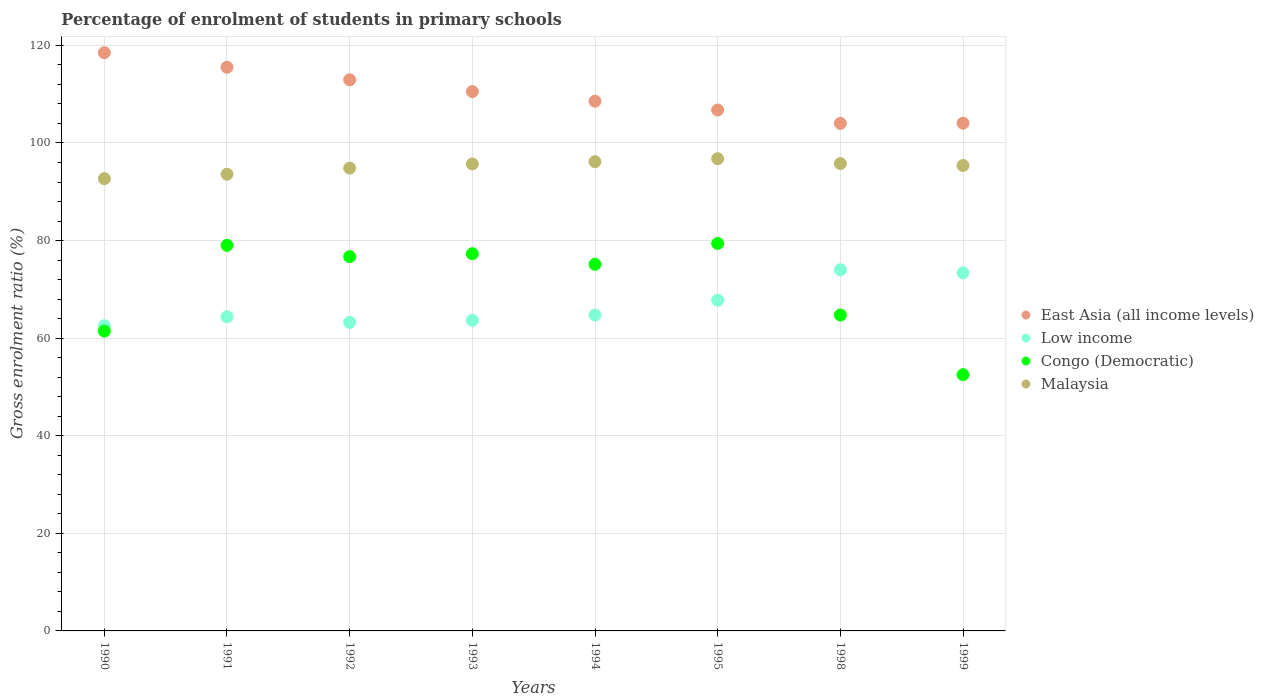Is the number of dotlines equal to the number of legend labels?
Make the answer very short. Yes. What is the percentage of students enrolled in primary schools in East Asia (all income levels) in 1993?
Give a very brief answer. 110.53. Across all years, what is the maximum percentage of students enrolled in primary schools in Low income?
Your response must be concise. 74.02. Across all years, what is the minimum percentage of students enrolled in primary schools in East Asia (all income levels)?
Ensure brevity in your answer.  104.02. In which year was the percentage of students enrolled in primary schools in Low income minimum?
Offer a terse response. 1990. What is the total percentage of students enrolled in primary schools in Low income in the graph?
Your answer should be compact. 533.71. What is the difference between the percentage of students enrolled in primary schools in Low income in 1998 and that in 1999?
Keep it short and to the point. 0.63. What is the difference between the percentage of students enrolled in primary schools in East Asia (all income levels) in 1991 and the percentage of students enrolled in primary schools in Malaysia in 1995?
Offer a very short reply. 18.74. What is the average percentage of students enrolled in primary schools in East Asia (all income levels) per year?
Keep it short and to the point. 110.11. In the year 1992, what is the difference between the percentage of students enrolled in primary schools in Congo (Democratic) and percentage of students enrolled in primary schools in Malaysia?
Ensure brevity in your answer.  -18.15. In how many years, is the percentage of students enrolled in primary schools in Malaysia greater than 44 %?
Keep it short and to the point. 8. What is the ratio of the percentage of students enrolled in primary schools in Congo (Democratic) in 1992 to that in 1998?
Your answer should be compact. 1.18. What is the difference between the highest and the second highest percentage of students enrolled in primary schools in Malaysia?
Your answer should be very brief. 0.61. What is the difference between the highest and the lowest percentage of students enrolled in primary schools in Congo (Democratic)?
Your answer should be very brief. 26.9. Is it the case that in every year, the sum of the percentage of students enrolled in primary schools in Congo (Democratic) and percentage of students enrolled in primary schools in Low income  is greater than the percentage of students enrolled in primary schools in Malaysia?
Your answer should be very brief. Yes. Does the percentage of students enrolled in primary schools in Congo (Democratic) monotonically increase over the years?
Keep it short and to the point. No. Is the percentage of students enrolled in primary schools in East Asia (all income levels) strictly less than the percentage of students enrolled in primary schools in Congo (Democratic) over the years?
Provide a short and direct response. No. What is the difference between two consecutive major ticks on the Y-axis?
Your response must be concise. 20. Are the values on the major ticks of Y-axis written in scientific E-notation?
Your response must be concise. No. Does the graph contain any zero values?
Offer a very short reply. No. Does the graph contain grids?
Your response must be concise. Yes. Where does the legend appear in the graph?
Make the answer very short. Center right. How are the legend labels stacked?
Provide a succinct answer. Vertical. What is the title of the graph?
Make the answer very short. Percentage of enrolment of students in primary schools. What is the Gross enrolment ratio (%) of East Asia (all income levels) in 1990?
Give a very brief answer. 118.51. What is the Gross enrolment ratio (%) of Low income in 1990?
Provide a succinct answer. 62.54. What is the Gross enrolment ratio (%) of Congo (Democratic) in 1990?
Offer a terse response. 61.45. What is the Gross enrolment ratio (%) of Malaysia in 1990?
Your answer should be very brief. 92.69. What is the Gross enrolment ratio (%) of East Asia (all income levels) in 1991?
Your answer should be compact. 115.52. What is the Gross enrolment ratio (%) of Low income in 1991?
Your answer should be very brief. 64.38. What is the Gross enrolment ratio (%) in Congo (Democratic) in 1991?
Offer a terse response. 79.03. What is the Gross enrolment ratio (%) of Malaysia in 1991?
Provide a short and direct response. 93.6. What is the Gross enrolment ratio (%) of East Asia (all income levels) in 1992?
Offer a very short reply. 112.94. What is the Gross enrolment ratio (%) of Low income in 1992?
Make the answer very short. 63.23. What is the Gross enrolment ratio (%) of Congo (Democratic) in 1992?
Your answer should be compact. 76.7. What is the Gross enrolment ratio (%) in Malaysia in 1992?
Keep it short and to the point. 94.85. What is the Gross enrolment ratio (%) of East Asia (all income levels) in 1993?
Your answer should be very brief. 110.53. What is the Gross enrolment ratio (%) in Low income in 1993?
Make the answer very short. 63.64. What is the Gross enrolment ratio (%) of Congo (Democratic) in 1993?
Your answer should be compact. 77.31. What is the Gross enrolment ratio (%) of Malaysia in 1993?
Your answer should be compact. 95.7. What is the Gross enrolment ratio (%) in East Asia (all income levels) in 1994?
Provide a succinct answer. 108.56. What is the Gross enrolment ratio (%) of Low income in 1994?
Offer a very short reply. 64.74. What is the Gross enrolment ratio (%) of Congo (Democratic) in 1994?
Ensure brevity in your answer.  75.14. What is the Gross enrolment ratio (%) of Malaysia in 1994?
Give a very brief answer. 96.17. What is the Gross enrolment ratio (%) of East Asia (all income levels) in 1995?
Your response must be concise. 106.77. What is the Gross enrolment ratio (%) of Low income in 1995?
Make the answer very short. 67.78. What is the Gross enrolment ratio (%) in Congo (Democratic) in 1995?
Keep it short and to the point. 79.41. What is the Gross enrolment ratio (%) of Malaysia in 1995?
Give a very brief answer. 96.78. What is the Gross enrolment ratio (%) in East Asia (all income levels) in 1998?
Keep it short and to the point. 104.02. What is the Gross enrolment ratio (%) in Low income in 1998?
Your response must be concise. 74.02. What is the Gross enrolment ratio (%) of Congo (Democratic) in 1998?
Provide a succinct answer. 64.74. What is the Gross enrolment ratio (%) in Malaysia in 1998?
Provide a short and direct response. 95.79. What is the Gross enrolment ratio (%) of East Asia (all income levels) in 1999?
Give a very brief answer. 104.06. What is the Gross enrolment ratio (%) in Low income in 1999?
Offer a very short reply. 73.39. What is the Gross enrolment ratio (%) in Congo (Democratic) in 1999?
Offer a terse response. 52.51. What is the Gross enrolment ratio (%) of Malaysia in 1999?
Make the answer very short. 95.39. Across all years, what is the maximum Gross enrolment ratio (%) in East Asia (all income levels)?
Your answer should be very brief. 118.51. Across all years, what is the maximum Gross enrolment ratio (%) in Low income?
Provide a short and direct response. 74.02. Across all years, what is the maximum Gross enrolment ratio (%) of Congo (Democratic)?
Offer a terse response. 79.41. Across all years, what is the maximum Gross enrolment ratio (%) of Malaysia?
Offer a very short reply. 96.78. Across all years, what is the minimum Gross enrolment ratio (%) of East Asia (all income levels)?
Keep it short and to the point. 104.02. Across all years, what is the minimum Gross enrolment ratio (%) of Low income?
Your response must be concise. 62.54. Across all years, what is the minimum Gross enrolment ratio (%) in Congo (Democratic)?
Provide a short and direct response. 52.51. Across all years, what is the minimum Gross enrolment ratio (%) in Malaysia?
Ensure brevity in your answer.  92.69. What is the total Gross enrolment ratio (%) of East Asia (all income levels) in the graph?
Ensure brevity in your answer.  880.91. What is the total Gross enrolment ratio (%) in Low income in the graph?
Keep it short and to the point. 533.71. What is the total Gross enrolment ratio (%) in Congo (Democratic) in the graph?
Your answer should be very brief. 566.28. What is the total Gross enrolment ratio (%) of Malaysia in the graph?
Make the answer very short. 760.97. What is the difference between the Gross enrolment ratio (%) in East Asia (all income levels) in 1990 and that in 1991?
Offer a terse response. 2.99. What is the difference between the Gross enrolment ratio (%) of Low income in 1990 and that in 1991?
Your response must be concise. -1.84. What is the difference between the Gross enrolment ratio (%) of Congo (Democratic) in 1990 and that in 1991?
Keep it short and to the point. -17.58. What is the difference between the Gross enrolment ratio (%) in Malaysia in 1990 and that in 1991?
Offer a terse response. -0.91. What is the difference between the Gross enrolment ratio (%) in East Asia (all income levels) in 1990 and that in 1992?
Give a very brief answer. 5.56. What is the difference between the Gross enrolment ratio (%) in Low income in 1990 and that in 1992?
Ensure brevity in your answer.  -0.69. What is the difference between the Gross enrolment ratio (%) of Congo (Democratic) in 1990 and that in 1992?
Ensure brevity in your answer.  -15.25. What is the difference between the Gross enrolment ratio (%) in Malaysia in 1990 and that in 1992?
Your answer should be very brief. -2.16. What is the difference between the Gross enrolment ratio (%) in East Asia (all income levels) in 1990 and that in 1993?
Your response must be concise. 7.98. What is the difference between the Gross enrolment ratio (%) in Low income in 1990 and that in 1993?
Offer a terse response. -1.1. What is the difference between the Gross enrolment ratio (%) of Congo (Democratic) in 1990 and that in 1993?
Provide a short and direct response. -15.86. What is the difference between the Gross enrolment ratio (%) of Malaysia in 1990 and that in 1993?
Make the answer very short. -3.01. What is the difference between the Gross enrolment ratio (%) in East Asia (all income levels) in 1990 and that in 1994?
Offer a very short reply. 9.94. What is the difference between the Gross enrolment ratio (%) in Low income in 1990 and that in 1994?
Your answer should be compact. -2.2. What is the difference between the Gross enrolment ratio (%) in Congo (Democratic) in 1990 and that in 1994?
Offer a very short reply. -13.69. What is the difference between the Gross enrolment ratio (%) in Malaysia in 1990 and that in 1994?
Ensure brevity in your answer.  -3.48. What is the difference between the Gross enrolment ratio (%) of East Asia (all income levels) in 1990 and that in 1995?
Give a very brief answer. 11.74. What is the difference between the Gross enrolment ratio (%) in Low income in 1990 and that in 1995?
Offer a very short reply. -5.24. What is the difference between the Gross enrolment ratio (%) of Congo (Democratic) in 1990 and that in 1995?
Ensure brevity in your answer.  -17.96. What is the difference between the Gross enrolment ratio (%) in Malaysia in 1990 and that in 1995?
Offer a very short reply. -4.09. What is the difference between the Gross enrolment ratio (%) of East Asia (all income levels) in 1990 and that in 1998?
Make the answer very short. 14.49. What is the difference between the Gross enrolment ratio (%) in Low income in 1990 and that in 1998?
Give a very brief answer. -11.48. What is the difference between the Gross enrolment ratio (%) in Congo (Democratic) in 1990 and that in 1998?
Keep it short and to the point. -3.29. What is the difference between the Gross enrolment ratio (%) in Malaysia in 1990 and that in 1998?
Your answer should be very brief. -3.1. What is the difference between the Gross enrolment ratio (%) of East Asia (all income levels) in 1990 and that in 1999?
Provide a succinct answer. 14.45. What is the difference between the Gross enrolment ratio (%) of Low income in 1990 and that in 1999?
Offer a very short reply. -10.85. What is the difference between the Gross enrolment ratio (%) in Congo (Democratic) in 1990 and that in 1999?
Your response must be concise. 8.93. What is the difference between the Gross enrolment ratio (%) in Malaysia in 1990 and that in 1999?
Keep it short and to the point. -2.69. What is the difference between the Gross enrolment ratio (%) in East Asia (all income levels) in 1991 and that in 1992?
Provide a short and direct response. 2.57. What is the difference between the Gross enrolment ratio (%) in Low income in 1991 and that in 1992?
Offer a terse response. 1.15. What is the difference between the Gross enrolment ratio (%) of Congo (Democratic) in 1991 and that in 1992?
Make the answer very short. 2.33. What is the difference between the Gross enrolment ratio (%) in Malaysia in 1991 and that in 1992?
Your answer should be compact. -1.25. What is the difference between the Gross enrolment ratio (%) of East Asia (all income levels) in 1991 and that in 1993?
Your response must be concise. 4.98. What is the difference between the Gross enrolment ratio (%) in Low income in 1991 and that in 1993?
Offer a terse response. 0.74. What is the difference between the Gross enrolment ratio (%) in Congo (Democratic) in 1991 and that in 1993?
Ensure brevity in your answer.  1.72. What is the difference between the Gross enrolment ratio (%) in Malaysia in 1991 and that in 1993?
Provide a short and direct response. -2.1. What is the difference between the Gross enrolment ratio (%) in East Asia (all income levels) in 1991 and that in 1994?
Keep it short and to the point. 6.95. What is the difference between the Gross enrolment ratio (%) of Low income in 1991 and that in 1994?
Your response must be concise. -0.37. What is the difference between the Gross enrolment ratio (%) of Congo (Democratic) in 1991 and that in 1994?
Give a very brief answer. 3.89. What is the difference between the Gross enrolment ratio (%) of Malaysia in 1991 and that in 1994?
Ensure brevity in your answer.  -2.57. What is the difference between the Gross enrolment ratio (%) in East Asia (all income levels) in 1991 and that in 1995?
Provide a short and direct response. 8.75. What is the difference between the Gross enrolment ratio (%) in Low income in 1991 and that in 1995?
Make the answer very short. -3.4. What is the difference between the Gross enrolment ratio (%) in Congo (Democratic) in 1991 and that in 1995?
Give a very brief answer. -0.38. What is the difference between the Gross enrolment ratio (%) in Malaysia in 1991 and that in 1995?
Your answer should be very brief. -3.18. What is the difference between the Gross enrolment ratio (%) of East Asia (all income levels) in 1991 and that in 1998?
Give a very brief answer. 11.5. What is the difference between the Gross enrolment ratio (%) in Low income in 1991 and that in 1998?
Make the answer very short. -9.64. What is the difference between the Gross enrolment ratio (%) in Congo (Democratic) in 1991 and that in 1998?
Provide a succinct answer. 14.29. What is the difference between the Gross enrolment ratio (%) in Malaysia in 1991 and that in 1998?
Provide a succinct answer. -2.19. What is the difference between the Gross enrolment ratio (%) in East Asia (all income levels) in 1991 and that in 1999?
Offer a very short reply. 11.46. What is the difference between the Gross enrolment ratio (%) of Low income in 1991 and that in 1999?
Give a very brief answer. -9.01. What is the difference between the Gross enrolment ratio (%) of Congo (Democratic) in 1991 and that in 1999?
Offer a very short reply. 26.51. What is the difference between the Gross enrolment ratio (%) of Malaysia in 1991 and that in 1999?
Provide a succinct answer. -1.78. What is the difference between the Gross enrolment ratio (%) in East Asia (all income levels) in 1992 and that in 1993?
Offer a terse response. 2.41. What is the difference between the Gross enrolment ratio (%) of Low income in 1992 and that in 1993?
Make the answer very short. -0.41. What is the difference between the Gross enrolment ratio (%) of Congo (Democratic) in 1992 and that in 1993?
Offer a very short reply. -0.6. What is the difference between the Gross enrolment ratio (%) in Malaysia in 1992 and that in 1993?
Give a very brief answer. -0.85. What is the difference between the Gross enrolment ratio (%) in East Asia (all income levels) in 1992 and that in 1994?
Your answer should be compact. 4.38. What is the difference between the Gross enrolment ratio (%) in Low income in 1992 and that in 1994?
Make the answer very short. -1.51. What is the difference between the Gross enrolment ratio (%) of Congo (Democratic) in 1992 and that in 1994?
Give a very brief answer. 1.56. What is the difference between the Gross enrolment ratio (%) of Malaysia in 1992 and that in 1994?
Give a very brief answer. -1.32. What is the difference between the Gross enrolment ratio (%) of East Asia (all income levels) in 1992 and that in 1995?
Make the answer very short. 6.18. What is the difference between the Gross enrolment ratio (%) in Low income in 1992 and that in 1995?
Your answer should be compact. -4.55. What is the difference between the Gross enrolment ratio (%) in Congo (Democratic) in 1992 and that in 1995?
Your response must be concise. -2.71. What is the difference between the Gross enrolment ratio (%) in Malaysia in 1992 and that in 1995?
Your answer should be compact. -1.93. What is the difference between the Gross enrolment ratio (%) of East Asia (all income levels) in 1992 and that in 1998?
Offer a very short reply. 8.92. What is the difference between the Gross enrolment ratio (%) of Low income in 1992 and that in 1998?
Offer a very short reply. -10.79. What is the difference between the Gross enrolment ratio (%) in Congo (Democratic) in 1992 and that in 1998?
Provide a succinct answer. 11.96. What is the difference between the Gross enrolment ratio (%) of Malaysia in 1992 and that in 1998?
Your answer should be very brief. -0.94. What is the difference between the Gross enrolment ratio (%) of East Asia (all income levels) in 1992 and that in 1999?
Your response must be concise. 8.88. What is the difference between the Gross enrolment ratio (%) in Low income in 1992 and that in 1999?
Provide a short and direct response. -10.16. What is the difference between the Gross enrolment ratio (%) of Congo (Democratic) in 1992 and that in 1999?
Your answer should be very brief. 24.19. What is the difference between the Gross enrolment ratio (%) in Malaysia in 1992 and that in 1999?
Provide a short and direct response. -0.54. What is the difference between the Gross enrolment ratio (%) in East Asia (all income levels) in 1993 and that in 1994?
Your answer should be compact. 1.97. What is the difference between the Gross enrolment ratio (%) in Low income in 1993 and that in 1994?
Provide a short and direct response. -1.1. What is the difference between the Gross enrolment ratio (%) of Congo (Democratic) in 1993 and that in 1994?
Your answer should be very brief. 2.17. What is the difference between the Gross enrolment ratio (%) in Malaysia in 1993 and that in 1994?
Give a very brief answer. -0.47. What is the difference between the Gross enrolment ratio (%) of East Asia (all income levels) in 1993 and that in 1995?
Provide a succinct answer. 3.77. What is the difference between the Gross enrolment ratio (%) in Low income in 1993 and that in 1995?
Your answer should be compact. -4.13. What is the difference between the Gross enrolment ratio (%) in Congo (Democratic) in 1993 and that in 1995?
Your response must be concise. -2.11. What is the difference between the Gross enrolment ratio (%) of Malaysia in 1993 and that in 1995?
Provide a succinct answer. -1.08. What is the difference between the Gross enrolment ratio (%) of East Asia (all income levels) in 1993 and that in 1998?
Your answer should be compact. 6.51. What is the difference between the Gross enrolment ratio (%) in Low income in 1993 and that in 1998?
Provide a succinct answer. -10.37. What is the difference between the Gross enrolment ratio (%) in Congo (Democratic) in 1993 and that in 1998?
Offer a terse response. 12.57. What is the difference between the Gross enrolment ratio (%) in Malaysia in 1993 and that in 1998?
Keep it short and to the point. -0.09. What is the difference between the Gross enrolment ratio (%) of East Asia (all income levels) in 1993 and that in 1999?
Provide a short and direct response. 6.47. What is the difference between the Gross enrolment ratio (%) of Low income in 1993 and that in 1999?
Your answer should be very brief. -9.75. What is the difference between the Gross enrolment ratio (%) of Congo (Democratic) in 1993 and that in 1999?
Make the answer very short. 24.79. What is the difference between the Gross enrolment ratio (%) in Malaysia in 1993 and that in 1999?
Give a very brief answer. 0.32. What is the difference between the Gross enrolment ratio (%) in East Asia (all income levels) in 1994 and that in 1995?
Your answer should be very brief. 1.8. What is the difference between the Gross enrolment ratio (%) in Low income in 1994 and that in 1995?
Offer a terse response. -3.03. What is the difference between the Gross enrolment ratio (%) in Congo (Democratic) in 1994 and that in 1995?
Offer a terse response. -4.27. What is the difference between the Gross enrolment ratio (%) of Malaysia in 1994 and that in 1995?
Give a very brief answer. -0.61. What is the difference between the Gross enrolment ratio (%) of East Asia (all income levels) in 1994 and that in 1998?
Provide a succinct answer. 4.54. What is the difference between the Gross enrolment ratio (%) of Low income in 1994 and that in 1998?
Your answer should be compact. -9.27. What is the difference between the Gross enrolment ratio (%) in Congo (Democratic) in 1994 and that in 1998?
Offer a terse response. 10.4. What is the difference between the Gross enrolment ratio (%) in Malaysia in 1994 and that in 1998?
Offer a very short reply. 0.38. What is the difference between the Gross enrolment ratio (%) of East Asia (all income levels) in 1994 and that in 1999?
Your answer should be compact. 4.51. What is the difference between the Gross enrolment ratio (%) in Low income in 1994 and that in 1999?
Your answer should be very brief. -8.64. What is the difference between the Gross enrolment ratio (%) in Congo (Democratic) in 1994 and that in 1999?
Make the answer very short. 22.63. What is the difference between the Gross enrolment ratio (%) in Malaysia in 1994 and that in 1999?
Offer a terse response. 0.78. What is the difference between the Gross enrolment ratio (%) of East Asia (all income levels) in 1995 and that in 1998?
Keep it short and to the point. 2.75. What is the difference between the Gross enrolment ratio (%) in Low income in 1995 and that in 1998?
Provide a succinct answer. -6.24. What is the difference between the Gross enrolment ratio (%) of Congo (Democratic) in 1995 and that in 1998?
Ensure brevity in your answer.  14.67. What is the difference between the Gross enrolment ratio (%) in Malaysia in 1995 and that in 1998?
Offer a terse response. 0.99. What is the difference between the Gross enrolment ratio (%) of East Asia (all income levels) in 1995 and that in 1999?
Offer a terse response. 2.71. What is the difference between the Gross enrolment ratio (%) of Low income in 1995 and that in 1999?
Your response must be concise. -5.61. What is the difference between the Gross enrolment ratio (%) in Congo (Democratic) in 1995 and that in 1999?
Provide a short and direct response. 26.9. What is the difference between the Gross enrolment ratio (%) in Malaysia in 1995 and that in 1999?
Your answer should be very brief. 1.39. What is the difference between the Gross enrolment ratio (%) in East Asia (all income levels) in 1998 and that in 1999?
Offer a very short reply. -0.04. What is the difference between the Gross enrolment ratio (%) in Low income in 1998 and that in 1999?
Provide a short and direct response. 0.63. What is the difference between the Gross enrolment ratio (%) in Congo (Democratic) in 1998 and that in 1999?
Offer a very short reply. 12.23. What is the difference between the Gross enrolment ratio (%) of Malaysia in 1998 and that in 1999?
Offer a very short reply. 0.4. What is the difference between the Gross enrolment ratio (%) in East Asia (all income levels) in 1990 and the Gross enrolment ratio (%) in Low income in 1991?
Ensure brevity in your answer.  54.13. What is the difference between the Gross enrolment ratio (%) in East Asia (all income levels) in 1990 and the Gross enrolment ratio (%) in Congo (Democratic) in 1991?
Make the answer very short. 39.48. What is the difference between the Gross enrolment ratio (%) in East Asia (all income levels) in 1990 and the Gross enrolment ratio (%) in Malaysia in 1991?
Keep it short and to the point. 24.91. What is the difference between the Gross enrolment ratio (%) in Low income in 1990 and the Gross enrolment ratio (%) in Congo (Democratic) in 1991?
Your answer should be very brief. -16.49. What is the difference between the Gross enrolment ratio (%) in Low income in 1990 and the Gross enrolment ratio (%) in Malaysia in 1991?
Your answer should be compact. -31.06. What is the difference between the Gross enrolment ratio (%) of Congo (Democratic) in 1990 and the Gross enrolment ratio (%) of Malaysia in 1991?
Make the answer very short. -32.15. What is the difference between the Gross enrolment ratio (%) in East Asia (all income levels) in 1990 and the Gross enrolment ratio (%) in Low income in 1992?
Your answer should be very brief. 55.28. What is the difference between the Gross enrolment ratio (%) in East Asia (all income levels) in 1990 and the Gross enrolment ratio (%) in Congo (Democratic) in 1992?
Ensure brevity in your answer.  41.81. What is the difference between the Gross enrolment ratio (%) of East Asia (all income levels) in 1990 and the Gross enrolment ratio (%) of Malaysia in 1992?
Keep it short and to the point. 23.66. What is the difference between the Gross enrolment ratio (%) of Low income in 1990 and the Gross enrolment ratio (%) of Congo (Democratic) in 1992?
Keep it short and to the point. -14.16. What is the difference between the Gross enrolment ratio (%) in Low income in 1990 and the Gross enrolment ratio (%) in Malaysia in 1992?
Offer a terse response. -32.31. What is the difference between the Gross enrolment ratio (%) in Congo (Democratic) in 1990 and the Gross enrolment ratio (%) in Malaysia in 1992?
Your answer should be very brief. -33.4. What is the difference between the Gross enrolment ratio (%) in East Asia (all income levels) in 1990 and the Gross enrolment ratio (%) in Low income in 1993?
Give a very brief answer. 54.87. What is the difference between the Gross enrolment ratio (%) in East Asia (all income levels) in 1990 and the Gross enrolment ratio (%) in Congo (Democratic) in 1993?
Your answer should be very brief. 41.2. What is the difference between the Gross enrolment ratio (%) of East Asia (all income levels) in 1990 and the Gross enrolment ratio (%) of Malaysia in 1993?
Your response must be concise. 22.8. What is the difference between the Gross enrolment ratio (%) of Low income in 1990 and the Gross enrolment ratio (%) of Congo (Democratic) in 1993?
Make the answer very short. -14.76. What is the difference between the Gross enrolment ratio (%) of Low income in 1990 and the Gross enrolment ratio (%) of Malaysia in 1993?
Give a very brief answer. -33.16. What is the difference between the Gross enrolment ratio (%) of Congo (Democratic) in 1990 and the Gross enrolment ratio (%) of Malaysia in 1993?
Your response must be concise. -34.25. What is the difference between the Gross enrolment ratio (%) of East Asia (all income levels) in 1990 and the Gross enrolment ratio (%) of Low income in 1994?
Offer a very short reply. 53.76. What is the difference between the Gross enrolment ratio (%) in East Asia (all income levels) in 1990 and the Gross enrolment ratio (%) in Congo (Democratic) in 1994?
Make the answer very short. 43.37. What is the difference between the Gross enrolment ratio (%) in East Asia (all income levels) in 1990 and the Gross enrolment ratio (%) in Malaysia in 1994?
Keep it short and to the point. 22.34. What is the difference between the Gross enrolment ratio (%) in Low income in 1990 and the Gross enrolment ratio (%) in Congo (Democratic) in 1994?
Keep it short and to the point. -12.6. What is the difference between the Gross enrolment ratio (%) in Low income in 1990 and the Gross enrolment ratio (%) in Malaysia in 1994?
Your answer should be very brief. -33.63. What is the difference between the Gross enrolment ratio (%) of Congo (Democratic) in 1990 and the Gross enrolment ratio (%) of Malaysia in 1994?
Your answer should be very brief. -34.72. What is the difference between the Gross enrolment ratio (%) in East Asia (all income levels) in 1990 and the Gross enrolment ratio (%) in Low income in 1995?
Provide a short and direct response. 50.73. What is the difference between the Gross enrolment ratio (%) in East Asia (all income levels) in 1990 and the Gross enrolment ratio (%) in Congo (Democratic) in 1995?
Give a very brief answer. 39.1. What is the difference between the Gross enrolment ratio (%) in East Asia (all income levels) in 1990 and the Gross enrolment ratio (%) in Malaysia in 1995?
Your answer should be compact. 21.73. What is the difference between the Gross enrolment ratio (%) in Low income in 1990 and the Gross enrolment ratio (%) in Congo (Democratic) in 1995?
Give a very brief answer. -16.87. What is the difference between the Gross enrolment ratio (%) of Low income in 1990 and the Gross enrolment ratio (%) of Malaysia in 1995?
Your answer should be very brief. -34.24. What is the difference between the Gross enrolment ratio (%) in Congo (Democratic) in 1990 and the Gross enrolment ratio (%) in Malaysia in 1995?
Ensure brevity in your answer.  -35.33. What is the difference between the Gross enrolment ratio (%) in East Asia (all income levels) in 1990 and the Gross enrolment ratio (%) in Low income in 1998?
Provide a short and direct response. 44.49. What is the difference between the Gross enrolment ratio (%) of East Asia (all income levels) in 1990 and the Gross enrolment ratio (%) of Congo (Democratic) in 1998?
Give a very brief answer. 53.77. What is the difference between the Gross enrolment ratio (%) in East Asia (all income levels) in 1990 and the Gross enrolment ratio (%) in Malaysia in 1998?
Keep it short and to the point. 22.72. What is the difference between the Gross enrolment ratio (%) of Low income in 1990 and the Gross enrolment ratio (%) of Congo (Democratic) in 1998?
Provide a succinct answer. -2.2. What is the difference between the Gross enrolment ratio (%) of Low income in 1990 and the Gross enrolment ratio (%) of Malaysia in 1998?
Your answer should be compact. -33.25. What is the difference between the Gross enrolment ratio (%) in Congo (Democratic) in 1990 and the Gross enrolment ratio (%) in Malaysia in 1998?
Offer a terse response. -34.34. What is the difference between the Gross enrolment ratio (%) of East Asia (all income levels) in 1990 and the Gross enrolment ratio (%) of Low income in 1999?
Your answer should be compact. 45.12. What is the difference between the Gross enrolment ratio (%) in East Asia (all income levels) in 1990 and the Gross enrolment ratio (%) in Congo (Democratic) in 1999?
Make the answer very short. 65.99. What is the difference between the Gross enrolment ratio (%) of East Asia (all income levels) in 1990 and the Gross enrolment ratio (%) of Malaysia in 1999?
Offer a very short reply. 23.12. What is the difference between the Gross enrolment ratio (%) of Low income in 1990 and the Gross enrolment ratio (%) of Congo (Democratic) in 1999?
Provide a short and direct response. 10.03. What is the difference between the Gross enrolment ratio (%) in Low income in 1990 and the Gross enrolment ratio (%) in Malaysia in 1999?
Your answer should be very brief. -32.84. What is the difference between the Gross enrolment ratio (%) in Congo (Democratic) in 1990 and the Gross enrolment ratio (%) in Malaysia in 1999?
Your response must be concise. -33.94. What is the difference between the Gross enrolment ratio (%) of East Asia (all income levels) in 1991 and the Gross enrolment ratio (%) of Low income in 1992?
Give a very brief answer. 52.29. What is the difference between the Gross enrolment ratio (%) in East Asia (all income levels) in 1991 and the Gross enrolment ratio (%) in Congo (Democratic) in 1992?
Your answer should be compact. 38.82. What is the difference between the Gross enrolment ratio (%) of East Asia (all income levels) in 1991 and the Gross enrolment ratio (%) of Malaysia in 1992?
Offer a very short reply. 20.67. What is the difference between the Gross enrolment ratio (%) of Low income in 1991 and the Gross enrolment ratio (%) of Congo (Democratic) in 1992?
Give a very brief answer. -12.32. What is the difference between the Gross enrolment ratio (%) in Low income in 1991 and the Gross enrolment ratio (%) in Malaysia in 1992?
Offer a terse response. -30.47. What is the difference between the Gross enrolment ratio (%) in Congo (Democratic) in 1991 and the Gross enrolment ratio (%) in Malaysia in 1992?
Ensure brevity in your answer.  -15.82. What is the difference between the Gross enrolment ratio (%) of East Asia (all income levels) in 1991 and the Gross enrolment ratio (%) of Low income in 1993?
Provide a succinct answer. 51.87. What is the difference between the Gross enrolment ratio (%) in East Asia (all income levels) in 1991 and the Gross enrolment ratio (%) in Congo (Democratic) in 1993?
Provide a succinct answer. 38.21. What is the difference between the Gross enrolment ratio (%) of East Asia (all income levels) in 1991 and the Gross enrolment ratio (%) of Malaysia in 1993?
Offer a terse response. 19.81. What is the difference between the Gross enrolment ratio (%) of Low income in 1991 and the Gross enrolment ratio (%) of Congo (Democratic) in 1993?
Provide a succinct answer. -12.93. What is the difference between the Gross enrolment ratio (%) in Low income in 1991 and the Gross enrolment ratio (%) in Malaysia in 1993?
Provide a succinct answer. -31.32. What is the difference between the Gross enrolment ratio (%) in Congo (Democratic) in 1991 and the Gross enrolment ratio (%) in Malaysia in 1993?
Give a very brief answer. -16.68. What is the difference between the Gross enrolment ratio (%) in East Asia (all income levels) in 1991 and the Gross enrolment ratio (%) in Low income in 1994?
Give a very brief answer. 50.77. What is the difference between the Gross enrolment ratio (%) of East Asia (all income levels) in 1991 and the Gross enrolment ratio (%) of Congo (Democratic) in 1994?
Offer a very short reply. 40.38. What is the difference between the Gross enrolment ratio (%) of East Asia (all income levels) in 1991 and the Gross enrolment ratio (%) of Malaysia in 1994?
Offer a very short reply. 19.35. What is the difference between the Gross enrolment ratio (%) in Low income in 1991 and the Gross enrolment ratio (%) in Congo (Democratic) in 1994?
Make the answer very short. -10.76. What is the difference between the Gross enrolment ratio (%) in Low income in 1991 and the Gross enrolment ratio (%) in Malaysia in 1994?
Keep it short and to the point. -31.79. What is the difference between the Gross enrolment ratio (%) of Congo (Democratic) in 1991 and the Gross enrolment ratio (%) of Malaysia in 1994?
Your answer should be compact. -17.14. What is the difference between the Gross enrolment ratio (%) of East Asia (all income levels) in 1991 and the Gross enrolment ratio (%) of Low income in 1995?
Your response must be concise. 47.74. What is the difference between the Gross enrolment ratio (%) in East Asia (all income levels) in 1991 and the Gross enrolment ratio (%) in Congo (Democratic) in 1995?
Make the answer very short. 36.11. What is the difference between the Gross enrolment ratio (%) of East Asia (all income levels) in 1991 and the Gross enrolment ratio (%) of Malaysia in 1995?
Your response must be concise. 18.74. What is the difference between the Gross enrolment ratio (%) of Low income in 1991 and the Gross enrolment ratio (%) of Congo (Democratic) in 1995?
Provide a short and direct response. -15.03. What is the difference between the Gross enrolment ratio (%) of Low income in 1991 and the Gross enrolment ratio (%) of Malaysia in 1995?
Your response must be concise. -32.4. What is the difference between the Gross enrolment ratio (%) in Congo (Democratic) in 1991 and the Gross enrolment ratio (%) in Malaysia in 1995?
Give a very brief answer. -17.75. What is the difference between the Gross enrolment ratio (%) in East Asia (all income levels) in 1991 and the Gross enrolment ratio (%) in Low income in 1998?
Ensure brevity in your answer.  41.5. What is the difference between the Gross enrolment ratio (%) in East Asia (all income levels) in 1991 and the Gross enrolment ratio (%) in Congo (Democratic) in 1998?
Provide a short and direct response. 50.78. What is the difference between the Gross enrolment ratio (%) in East Asia (all income levels) in 1991 and the Gross enrolment ratio (%) in Malaysia in 1998?
Keep it short and to the point. 19.73. What is the difference between the Gross enrolment ratio (%) in Low income in 1991 and the Gross enrolment ratio (%) in Congo (Democratic) in 1998?
Your answer should be very brief. -0.36. What is the difference between the Gross enrolment ratio (%) of Low income in 1991 and the Gross enrolment ratio (%) of Malaysia in 1998?
Your answer should be very brief. -31.41. What is the difference between the Gross enrolment ratio (%) in Congo (Democratic) in 1991 and the Gross enrolment ratio (%) in Malaysia in 1998?
Provide a short and direct response. -16.76. What is the difference between the Gross enrolment ratio (%) in East Asia (all income levels) in 1991 and the Gross enrolment ratio (%) in Low income in 1999?
Give a very brief answer. 42.13. What is the difference between the Gross enrolment ratio (%) in East Asia (all income levels) in 1991 and the Gross enrolment ratio (%) in Congo (Democratic) in 1999?
Give a very brief answer. 63. What is the difference between the Gross enrolment ratio (%) in East Asia (all income levels) in 1991 and the Gross enrolment ratio (%) in Malaysia in 1999?
Give a very brief answer. 20.13. What is the difference between the Gross enrolment ratio (%) of Low income in 1991 and the Gross enrolment ratio (%) of Congo (Democratic) in 1999?
Your response must be concise. 11.86. What is the difference between the Gross enrolment ratio (%) in Low income in 1991 and the Gross enrolment ratio (%) in Malaysia in 1999?
Keep it short and to the point. -31.01. What is the difference between the Gross enrolment ratio (%) in Congo (Democratic) in 1991 and the Gross enrolment ratio (%) in Malaysia in 1999?
Make the answer very short. -16.36. What is the difference between the Gross enrolment ratio (%) in East Asia (all income levels) in 1992 and the Gross enrolment ratio (%) in Low income in 1993?
Keep it short and to the point. 49.3. What is the difference between the Gross enrolment ratio (%) of East Asia (all income levels) in 1992 and the Gross enrolment ratio (%) of Congo (Democratic) in 1993?
Your answer should be very brief. 35.64. What is the difference between the Gross enrolment ratio (%) of East Asia (all income levels) in 1992 and the Gross enrolment ratio (%) of Malaysia in 1993?
Give a very brief answer. 17.24. What is the difference between the Gross enrolment ratio (%) of Low income in 1992 and the Gross enrolment ratio (%) of Congo (Democratic) in 1993?
Provide a short and direct response. -14.08. What is the difference between the Gross enrolment ratio (%) in Low income in 1992 and the Gross enrolment ratio (%) in Malaysia in 1993?
Offer a terse response. -32.47. What is the difference between the Gross enrolment ratio (%) in Congo (Democratic) in 1992 and the Gross enrolment ratio (%) in Malaysia in 1993?
Make the answer very short. -19. What is the difference between the Gross enrolment ratio (%) of East Asia (all income levels) in 1992 and the Gross enrolment ratio (%) of Low income in 1994?
Provide a succinct answer. 48.2. What is the difference between the Gross enrolment ratio (%) of East Asia (all income levels) in 1992 and the Gross enrolment ratio (%) of Congo (Democratic) in 1994?
Your answer should be very brief. 37.8. What is the difference between the Gross enrolment ratio (%) of East Asia (all income levels) in 1992 and the Gross enrolment ratio (%) of Malaysia in 1994?
Your response must be concise. 16.77. What is the difference between the Gross enrolment ratio (%) of Low income in 1992 and the Gross enrolment ratio (%) of Congo (Democratic) in 1994?
Give a very brief answer. -11.91. What is the difference between the Gross enrolment ratio (%) in Low income in 1992 and the Gross enrolment ratio (%) in Malaysia in 1994?
Your response must be concise. -32.94. What is the difference between the Gross enrolment ratio (%) in Congo (Democratic) in 1992 and the Gross enrolment ratio (%) in Malaysia in 1994?
Keep it short and to the point. -19.47. What is the difference between the Gross enrolment ratio (%) in East Asia (all income levels) in 1992 and the Gross enrolment ratio (%) in Low income in 1995?
Ensure brevity in your answer.  45.17. What is the difference between the Gross enrolment ratio (%) of East Asia (all income levels) in 1992 and the Gross enrolment ratio (%) of Congo (Democratic) in 1995?
Your response must be concise. 33.53. What is the difference between the Gross enrolment ratio (%) in East Asia (all income levels) in 1992 and the Gross enrolment ratio (%) in Malaysia in 1995?
Offer a very short reply. 16.16. What is the difference between the Gross enrolment ratio (%) in Low income in 1992 and the Gross enrolment ratio (%) in Congo (Democratic) in 1995?
Your response must be concise. -16.18. What is the difference between the Gross enrolment ratio (%) in Low income in 1992 and the Gross enrolment ratio (%) in Malaysia in 1995?
Ensure brevity in your answer.  -33.55. What is the difference between the Gross enrolment ratio (%) of Congo (Democratic) in 1992 and the Gross enrolment ratio (%) of Malaysia in 1995?
Keep it short and to the point. -20.08. What is the difference between the Gross enrolment ratio (%) of East Asia (all income levels) in 1992 and the Gross enrolment ratio (%) of Low income in 1998?
Give a very brief answer. 38.93. What is the difference between the Gross enrolment ratio (%) of East Asia (all income levels) in 1992 and the Gross enrolment ratio (%) of Congo (Democratic) in 1998?
Give a very brief answer. 48.2. What is the difference between the Gross enrolment ratio (%) of East Asia (all income levels) in 1992 and the Gross enrolment ratio (%) of Malaysia in 1998?
Offer a terse response. 17.15. What is the difference between the Gross enrolment ratio (%) in Low income in 1992 and the Gross enrolment ratio (%) in Congo (Democratic) in 1998?
Make the answer very short. -1.51. What is the difference between the Gross enrolment ratio (%) in Low income in 1992 and the Gross enrolment ratio (%) in Malaysia in 1998?
Provide a succinct answer. -32.56. What is the difference between the Gross enrolment ratio (%) in Congo (Democratic) in 1992 and the Gross enrolment ratio (%) in Malaysia in 1998?
Give a very brief answer. -19.09. What is the difference between the Gross enrolment ratio (%) of East Asia (all income levels) in 1992 and the Gross enrolment ratio (%) of Low income in 1999?
Your answer should be compact. 39.56. What is the difference between the Gross enrolment ratio (%) of East Asia (all income levels) in 1992 and the Gross enrolment ratio (%) of Congo (Democratic) in 1999?
Make the answer very short. 60.43. What is the difference between the Gross enrolment ratio (%) in East Asia (all income levels) in 1992 and the Gross enrolment ratio (%) in Malaysia in 1999?
Give a very brief answer. 17.56. What is the difference between the Gross enrolment ratio (%) in Low income in 1992 and the Gross enrolment ratio (%) in Congo (Democratic) in 1999?
Ensure brevity in your answer.  10.72. What is the difference between the Gross enrolment ratio (%) of Low income in 1992 and the Gross enrolment ratio (%) of Malaysia in 1999?
Provide a succinct answer. -32.16. What is the difference between the Gross enrolment ratio (%) in Congo (Democratic) in 1992 and the Gross enrolment ratio (%) in Malaysia in 1999?
Provide a succinct answer. -18.69. What is the difference between the Gross enrolment ratio (%) of East Asia (all income levels) in 1993 and the Gross enrolment ratio (%) of Low income in 1994?
Offer a terse response. 45.79. What is the difference between the Gross enrolment ratio (%) of East Asia (all income levels) in 1993 and the Gross enrolment ratio (%) of Congo (Democratic) in 1994?
Provide a short and direct response. 35.39. What is the difference between the Gross enrolment ratio (%) of East Asia (all income levels) in 1993 and the Gross enrolment ratio (%) of Malaysia in 1994?
Your answer should be very brief. 14.36. What is the difference between the Gross enrolment ratio (%) of Low income in 1993 and the Gross enrolment ratio (%) of Congo (Democratic) in 1994?
Your answer should be very brief. -11.5. What is the difference between the Gross enrolment ratio (%) of Low income in 1993 and the Gross enrolment ratio (%) of Malaysia in 1994?
Your answer should be very brief. -32.53. What is the difference between the Gross enrolment ratio (%) of Congo (Democratic) in 1993 and the Gross enrolment ratio (%) of Malaysia in 1994?
Provide a succinct answer. -18.86. What is the difference between the Gross enrolment ratio (%) in East Asia (all income levels) in 1993 and the Gross enrolment ratio (%) in Low income in 1995?
Offer a very short reply. 42.76. What is the difference between the Gross enrolment ratio (%) in East Asia (all income levels) in 1993 and the Gross enrolment ratio (%) in Congo (Democratic) in 1995?
Make the answer very short. 31.12. What is the difference between the Gross enrolment ratio (%) of East Asia (all income levels) in 1993 and the Gross enrolment ratio (%) of Malaysia in 1995?
Offer a very short reply. 13.75. What is the difference between the Gross enrolment ratio (%) of Low income in 1993 and the Gross enrolment ratio (%) of Congo (Democratic) in 1995?
Your answer should be very brief. -15.77. What is the difference between the Gross enrolment ratio (%) of Low income in 1993 and the Gross enrolment ratio (%) of Malaysia in 1995?
Keep it short and to the point. -33.14. What is the difference between the Gross enrolment ratio (%) in Congo (Democratic) in 1993 and the Gross enrolment ratio (%) in Malaysia in 1995?
Provide a succinct answer. -19.47. What is the difference between the Gross enrolment ratio (%) in East Asia (all income levels) in 1993 and the Gross enrolment ratio (%) in Low income in 1998?
Keep it short and to the point. 36.52. What is the difference between the Gross enrolment ratio (%) in East Asia (all income levels) in 1993 and the Gross enrolment ratio (%) in Congo (Democratic) in 1998?
Your answer should be compact. 45.79. What is the difference between the Gross enrolment ratio (%) of East Asia (all income levels) in 1993 and the Gross enrolment ratio (%) of Malaysia in 1998?
Provide a succinct answer. 14.74. What is the difference between the Gross enrolment ratio (%) in Low income in 1993 and the Gross enrolment ratio (%) in Congo (Democratic) in 1998?
Provide a succinct answer. -1.1. What is the difference between the Gross enrolment ratio (%) of Low income in 1993 and the Gross enrolment ratio (%) of Malaysia in 1998?
Make the answer very short. -32.15. What is the difference between the Gross enrolment ratio (%) of Congo (Democratic) in 1993 and the Gross enrolment ratio (%) of Malaysia in 1998?
Ensure brevity in your answer.  -18.49. What is the difference between the Gross enrolment ratio (%) of East Asia (all income levels) in 1993 and the Gross enrolment ratio (%) of Low income in 1999?
Offer a very short reply. 37.14. What is the difference between the Gross enrolment ratio (%) in East Asia (all income levels) in 1993 and the Gross enrolment ratio (%) in Congo (Democratic) in 1999?
Make the answer very short. 58.02. What is the difference between the Gross enrolment ratio (%) of East Asia (all income levels) in 1993 and the Gross enrolment ratio (%) of Malaysia in 1999?
Your answer should be compact. 15.15. What is the difference between the Gross enrolment ratio (%) in Low income in 1993 and the Gross enrolment ratio (%) in Congo (Democratic) in 1999?
Your answer should be compact. 11.13. What is the difference between the Gross enrolment ratio (%) in Low income in 1993 and the Gross enrolment ratio (%) in Malaysia in 1999?
Offer a very short reply. -31.74. What is the difference between the Gross enrolment ratio (%) of Congo (Democratic) in 1993 and the Gross enrolment ratio (%) of Malaysia in 1999?
Give a very brief answer. -18.08. What is the difference between the Gross enrolment ratio (%) of East Asia (all income levels) in 1994 and the Gross enrolment ratio (%) of Low income in 1995?
Your response must be concise. 40.79. What is the difference between the Gross enrolment ratio (%) of East Asia (all income levels) in 1994 and the Gross enrolment ratio (%) of Congo (Democratic) in 1995?
Keep it short and to the point. 29.15. What is the difference between the Gross enrolment ratio (%) in East Asia (all income levels) in 1994 and the Gross enrolment ratio (%) in Malaysia in 1995?
Provide a short and direct response. 11.79. What is the difference between the Gross enrolment ratio (%) in Low income in 1994 and the Gross enrolment ratio (%) in Congo (Democratic) in 1995?
Keep it short and to the point. -14.67. What is the difference between the Gross enrolment ratio (%) of Low income in 1994 and the Gross enrolment ratio (%) of Malaysia in 1995?
Your answer should be compact. -32.03. What is the difference between the Gross enrolment ratio (%) of Congo (Democratic) in 1994 and the Gross enrolment ratio (%) of Malaysia in 1995?
Keep it short and to the point. -21.64. What is the difference between the Gross enrolment ratio (%) in East Asia (all income levels) in 1994 and the Gross enrolment ratio (%) in Low income in 1998?
Keep it short and to the point. 34.55. What is the difference between the Gross enrolment ratio (%) in East Asia (all income levels) in 1994 and the Gross enrolment ratio (%) in Congo (Democratic) in 1998?
Ensure brevity in your answer.  43.82. What is the difference between the Gross enrolment ratio (%) in East Asia (all income levels) in 1994 and the Gross enrolment ratio (%) in Malaysia in 1998?
Ensure brevity in your answer.  12.77. What is the difference between the Gross enrolment ratio (%) of Low income in 1994 and the Gross enrolment ratio (%) of Congo (Democratic) in 1998?
Your answer should be compact. 0. What is the difference between the Gross enrolment ratio (%) in Low income in 1994 and the Gross enrolment ratio (%) in Malaysia in 1998?
Offer a very short reply. -31.05. What is the difference between the Gross enrolment ratio (%) of Congo (Democratic) in 1994 and the Gross enrolment ratio (%) of Malaysia in 1998?
Offer a terse response. -20.65. What is the difference between the Gross enrolment ratio (%) of East Asia (all income levels) in 1994 and the Gross enrolment ratio (%) of Low income in 1999?
Your answer should be very brief. 35.18. What is the difference between the Gross enrolment ratio (%) of East Asia (all income levels) in 1994 and the Gross enrolment ratio (%) of Congo (Democratic) in 1999?
Give a very brief answer. 56.05. What is the difference between the Gross enrolment ratio (%) of East Asia (all income levels) in 1994 and the Gross enrolment ratio (%) of Malaysia in 1999?
Ensure brevity in your answer.  13.18. What is the difference between the Gross enrolment ratio (%) in Low income in 1994 and the Gross enrolment ratio (%) in Congo (Democratic) in 1999?
Give a very brief answer. 12.23. What is the difference between the Gross enrolment ratio (%) in Low income in 1994 and the Gross enrolment ratio (%) in Malaysia in 1999?
Make the answer very short. -30.64. What is the difference between the Gross enrolment ratio (%) of Congo (Democratic) in 1994 and the Gross enrolment ratio (%) of Malaysia in 1999?
Give a very brief answer. -20.25. What is the difference between the Gross enrolment ratio (%) in East Asia (all income levels) in 1995 and the Gross enrolment ratio (%) in Low income in 1998?
Offer a terse response. 32.75. What is the difference between the Gross enrolment ratio (%) of East Asia (all income levels) in 1995 and the Gross enrolment ratio (%) of Congo (Democratic) in 1998?
Give a very brief answer. 42.03. What is the difference between the Gross enrolment ratio (%) of East Asia (all income levels) in 1995 and the Gross enrolment ratio (%) of Malaysia in 1998?
Provide a succinct answer. 10.98. What is the difference between the Gross enrolment ratio (%) of Low income in 1995 and the Gross enrolment ratio (%) of Congo (Democratic) in 1998?
Provide a short and direct response. 3.04. What is the difference between the Gross enrolment ratio (%) in Low income in 1995 and the Gross enrolment ratio (%) in Malaysia in 1998?
Offer a terse response. -28.01. What is the difference between the Gross enrolment ratio (%) in Congo (Democratic) in 1995 and the Gross enrolment ratio (%) in Malaysia in 1998?
Offer a terse response. -16.38. What is the difference between the Gross enrolment ratio (%) of East Asia (all income levels) in 1995 and the Gross enrolment ratio (%) of Low income in 1999?
Your answer should be very brief. 33.38. What is the difference between the Gross enrolment ratio (%) of East Asia (all income levels) in 1995 and the Gross enrolment ratio (%) of Congo (Democratic) in 1999?
Offer a terse response. 54.25. What is the difference between the Gross enrolment ratio (%) of East Asia (all income levels) in 1995 and the Gross enrolment ratio (%) of Malaysia in 1999?
Give a very brief answer. 11.38. What is the difference between the Gross enrolment ratio (%) in Low income in 1995 and the Gross enrolment ratio (%) in Congo (Democratic) in 1999?
Your response must be concise. 15.26. What is the difference between the Gross enrolment ratio (%) in Low income in 1995 and the Gross enrolment ratio (%) in Malaysia in 1999?
Make the answer very short. -27.61. What is the difference between the Gross enrolment ratio (%) of Congo (Democratic) in 1995 and the Gross enrolment ratio (%) of Malaysia in 1999?
Keep it short and to the point. -15.97. What is the difference between the Gross enrolment ratio (%) of East Asia (all income levels) in 1998 and the Gross enrolment ratio (%) of Low income in 1999?
Your answer should be very brief. 30.63. What is the difference between the Gross enrolment ratio (%) in East Asia (all income levels) in 1998 and the Gross enrolment ratio (%) in Congo (Democratic) in 1999?
Keep it short and to the point. 51.51. What is the difference between the Gross enrolment ratio (%) in East Asia (all income levels) in 1998 and the Gross enrolment ratio (%) in Malaysia in 1999?
Offer a terse response. 8.63. What is the difference between the Gross enrolment ratio (%) of Low income in 1998 and the Gross enrolment ratio (%) of Congo (Democratic) in 1999?
Your answer should be very brief. 21.5. What is the difference between the Gross enrolment ratio (%) in Low income in 1998 and the Gross enrolment ratio (%) in Malaysia in 1999?
Offer a very short reply. -21.37. What is the difference between the Gross enrolment ratio (%) of Congo (Democratic) in 1998 and the Gross enrolment ratio (%) of Malaysia in 1999?
Keep it short and to the point. -30.65. What is the average Gross enrolment ratio (%) of East Asia (all income levels) per year?
Give a very brief answer. 110.11. What is the average Gross enrolment ratio (%) of Low income per year?
Ensure brevity in your answer.  66.71. What is the average Gross enrolment ratio (%) of Congo (Democratic) per year?
Keep it short and to the point. 70.79. What is the average Gross enrolment ratio (%) in Malaysia per year?
Offer a very short reply. 95.12. In the year 1990, what is the difference between the Gross enrolment ratio (%) in East Asia (all income levels) and Gross enrolment ratio (%) in Low income?
Offer a terse response. 55.97. In the year 1990, what is the difference between the Gross enrolment ratio (%) in East Asia (all income levels) and Gross enrolment ratio (%) in Congo (Democratic)?
Offer a terse response. 57.06. In the year 1990, what is the difference between the Gross enrolment ratio (%) in East Asia (all income levels) and Gross enrolment ratio (%) in Malaysia?
Your answer should be very brief. 25.82. In the year 1990, what is the difference between the Gross enrolment ratio (%) of Low income and Gross enrolment ratio (%) of Congo (Democratic)?
Your response must be concise. 1.09. In the year 1990, what is the difference between the Gross enrolment ratio (%) of Low income and Gross enrolment ratio (%) of Malaysia?
Keep it short and to the point. -30.15. In the year 1990, what is the difference between the Gross enrolment ratio (%) of Congo (Democratic) and Gross enrolment ratio (%) of Malaysia?
Your response must be concise. -31.24. In the year 1991, what is the difference between the Gross enrolment ratio (%) in East Asia (all income levels) and Gross enrolment ratio (%) in Low income?
Your response must be concise. 51.14. In the year 1991, what is the difference between the Gross enrolment ratio (%) in East Asia (all income levels) and Gross enrolment ratio (%) in Congo (Democratic)?
Make the answer very short. 36.49. In the year 1991, what is the difference between the Gross enrolment ratio (%) in East Asia (all income levels) and Gross enrolment ratio (%) in Malaysia?
Your answer should be compact. 21.91. In the year 1991, what is the difference between the Gross enrolment ratio (%) of Low income and Gross enrolment ratio (%) of Congo (Democratic)?
Offer a very short reply. -14.65. In the year 1991, what is the difference between the Gross enrolment ratio (%) in Low income and Gross enrolment ratio (%) in Malaysia?
Make the answer very short. -29.22. In the year 1991, what is the difference between the Gross enrolment ratio (%) of Congo (Democratic) and Gross enrolment ratio (%) of Malaysia?
Keep it short and to the point. -14.57. In the year 1992, what is the difference between the Gross enrolment ratio (%) of East Asia (all income levels) and Gross enrolment ratio (%) of Low income?
Your answer should be compact. 49.71. In the year 1992, what is the difference between the Gross enrolment ratio (%) in East Asia (all income levels) and Gross enrolment ratio (%) in Congo (Democratic)?
Give a very brief answer. 36.24. In the year 1992, what is the difference between the Gross enrolment ratio (%) of East Asia (all income levels) and Gross enrolment ratio (%) of Malaysia?
Keep it short and to the point. 18.09. In the year 1992, what is the difference between the Gross enrolment ratio (%) of Low income and Gross enrolment ratio (%) of Congo (Democratic)?
Your answer should be very brief. -13.47. In the year 1992, what is the difference between the Gross enrolment ratio (%) of Low income and Gross enrolment ratio (%) of Malaysia?
Offer a very short reply. -31.62. In the year 1992, what is the difference between the Gross enrolment ratio (%) in Congo (Democratic) and Gross enrolment ratio (%) in Malaysia?
Your response must be concise. -18.15. In the year 1993, what is the difference between the Gross enrolment ratio (%) in East Asia (all income levels) and Gross enrolment ratio (%) in Low income?
Keep it short and to the point. 46.89. In the year 1993, what is the difference between the Gross enrolment ratio (%) in East Asia (all income levels) and Gross enrolment ratio (%) in Congo (Democratic)?
Keep it short and to the point. 33.23. In the year 1993, what is the difference between the Gross enrolment ratio (%) in East Asia (all income levels) and Gross enrolment ratio (%) in Malaysia?
Provide a succinct answer. 14.83. In the year 1993, what is the difference between the Gross enrolment ratio (%) of Low income and Gross enrolment ratio (%) of Congo (Democratic)?
Your answer should be very brief. -13.66. In the year 1993, what is the difference between the Gross enrolment ratio (%) in Low income and Gross enrolment ratio (%) in Malaysia?
Keep it short and to the point. -32.06. In the year 1993, what is the difference between the Gross enrolment ratio (%) of Congo (Democratic) and Gross enrolment ratio (%) of Malaysia?
Provide a succinct answer. -18.4. In the year 1994, what is the difference between the Gross enrolment ratio (%) in East Asia (all income levels) and Gross enrolment ratio (%) in Low income?
Ensure brevity in your answer.  43.82. In the year 1994, what is the difference between the Gross enrolment ratio (%) of East Asia (all income levels) and Gross enrolment ratio (%) of Congo (Democratic)?
Offer a very short reply. 33.43. In the year 1994, what is the difference between the Gross enrolment ratio (%) in East Asia (all income levels) and Gross enrolment ratio (%) in Malaysia?
Keep it short and to the point. 12.4. In the year 1994, what is the difference between the Gross enrolment ratio (%) in Low income and Gross enrolment ratio (%) in Congo (Democratic)?
Keep it short and to the point. -10.4. In the year 1994, what is the difference between the Gross enrolment ratio (%) in Low income and Gross enrolment ratio (%) in Malaysia?
Your answer should be compact. -31.43. In the year 1994, what is the difference between the Gross enrolment ratio (%) of Congo (Democratic) and Gross enrolment ratio (%) of Malaysia?
Keep it short and to the point. -21.03. In the year 1995, what is the difference between the Gross enrolment ratio (%) of East Asia (all income levels) and Gross enrolment ratio (%) of Low income?
Keep it short and to the point. 38.99. In the year 1995, what is the difference between the Gross enrolment ratio (%) in East Asia (all income levels) and Gross enrolment ratio (%) in Congo (Democratic)?
Your answer should be compact. 27.36. In the year 1995, what is the difference between the Gross enrolment ratio (%) in East Asia (all income levels) and Gross enrolment ratio (%) in Malaysia?
Offer a very short reply. 9.99. In the year 1995, what is the difference between the Gross enrolment ratio (%) of Low income and Gross enrolment ratio (%) of Congo (Democratic)?
Your answer should be compact. -11.63. In the year 1995, what is the difference between the Gross enrolment ratio (%) of Low income and Gross enrolment ratio (%) of Malaysia?
Keep it short and to the point. -29. In the year 1995, what is the difference between the Gross enrolment ratio (%) of Congo (Democratic) and Gross enrolment ratio (%) of Malaysia?
Your response must be concise. -17.37. In the year 1998, what is the difference between the Gross enrolment ratio (%) in East Asia (all income levels) and Gross enrolment ratio (%) in Low income?
Ensure brevity in your answer.  30. In the year 1998, what is the difference between the Gross enrolment ratio (%) of East Asia (all income levels) and Gross enrolment ratio (%) of Congo (Democratic)?
Your answer should be very brief. 39.28. In the year 1998, what is the difference between the Gross enrolment ratio (%) in East Asia (all income levels) and Gross enrolment ratio (%) in Malaysia?
Your answer should be compact. 8.23. In the year 1998, what is the difference between the Gross enrolment ratio (%) of Low income and Gross enrolment ratio (%) of Congo (Democratic)?
Offer a very short reply. 9.28. In the year 1998, what is the difference between the Gross enrolment ratio (%) of Low income and Gross enrolment ratio (%) of Malaysia?
Give a very brief answer. -21.77. In the year 1998, what is the difference between the Gross enrolment ratio (%) of Congo (Democratic) and Gross enrolment ratio (%) of Malaysia?
Your answer should be compact. -31.05. In the year 1999, what is the difference between the Gross enrolment ratio (%) in East Asia (all income levels) and Gross enrolment ratio (%) in Low income?
Your answer should be compact. 30.67. In the year 1999, what is the difference between the Gross enrolment ratio (%) in East Asia (all income levels) and Gross enrolment ratio (%) in Congo (Democratic)?
Keep it short and to the point. 51.55. In the year 1999, what is the difference between the Gross enrolment ratio (%) in East Asia (all income levels) and Gross enrolment ratio (%) in Malaysia?
Make the answer very short. 8.67. In the year 1999, what is the difference between the Gross enrolment ratio (%) in Low income and Gross enrolment ratio (%) in Congo (Democratic)?
Keep it short and to the point. 20.87. In the year 1999, what is the difference between the Gross enrolment ratio (%) in Low income and Gross enrolment ratio (%) in Malaysia?
Your answer should be very brief. -22. In the year 1999, what is the difference between the Gross enrolment ratio (%) of Congo (Democratic) and Gross enrolment ratio (%) of Malaysia?
Provide a succinct answer. -42.87. What is the ratio of the Gross enrolment ratio (%) in East Asia (all income levels) in 1990 to that in 1991?
Keep it short and to the point. 1.03. What is the ratio of the Gross enrolment ratio (%) in Low income in 1990 to that in 1991?
Your answer should be compact. 0.97. What is the ratio of the Gross enrolment ratio (%) in Congo (Democratic) in 1990 to that in 1991?
Give a very brief answer. 0.78. What is the ratio of the Gross enrolment ratio (%) of Malaysia in 1990 to that in 1991?
Give a very brief answer. 0.99. What is the ratio of the Gross enrolment ratio (%) of East Asia (all income levels) in 1990 to that in 1992?
Offer a terse response. 1.05. What is the ratio of the Gross enrolment ratio (%) of Low income in 1990 to that in 1992?
Your response must be concise. 0.99. What is the ratio of the Gross enrolment ratio (%) in Congo (Democratic) in 1990 to that in 1992?
Offer a terse response. 0.8. What is the ratio of the Gross enrolment ratio (%) in Malaysia in 1990 to that in 1992?
Offer a terse response. 0.98. What is the ratio of the Gross enrolment ratio (%) in East Asia (all income levels) in 1990 to that in 1993?
Keep it short and to the point. 1.07. What is the ratio of the Gross enrolment ratio (%) of Low income in 1990 to that in 1993?
Make the answer very short. 0.98. What is the ratio of the Gross enrolment ratio (%) in Congo (Democratic) in 1990 to that in 1993?
Keep it short and to the point. 0.79. What is the ratio of the Gross enrolment ratio (%) of Malaysia in 1990 to that in 1993?
Provide a short and direct response. 0.97. What is the ratio of the Gross enrolment ratio (%) in East Asia (all income levels) in 1990 to that in 1994?
Give a very brief answer. 1.09. What is the ratio of the Gross enrolment ratio (%) of Low income in 1990 to that in 1994?
Your response must be concise. 0.97. What is the ratio of the Gross enrolment ratio (%) of Congo (Democratic) in 1990 to that in 1994?
Make the answer very short. 0.82. What is the ratio of the Gross enrolment ratio (%) in Malaysia in 1990 to that in 1994?
Your response must be concise. 0.96. What is the ratio of the Gross enrolment ratio (%) of East Asia (all income levels) in 1990 to that in 1995?
Your answer should be very brief. 1.11. What is the ratio of the Gross enrolment ratio (%) of Low income in 1990 to that in 1995?
Your response must be concise. 0.92. What is the ratio of the Gross enrolment ratio (%) in Congo (Democratic) in 1990 to that in 1995?
Provide a short and direct response. 0.77. What is the ratio of the Gross enrolment ratio (%) of Malaysia in 1990 to that in 1995?
Give a very brief answer. 0.96. What is the ratio of the Gross enrolment ratio (%) of East Asia (all income levels) in 1990 to that in 1998?
Keep it short and to the point. 1.14. What is the ratio of the Gross enrolment ratio (%) of Low income in 1990 to that in 1998?
Provide a short and direct response. 0.84. What is the ratio of the Gross enrolment ratio (%) of Congo (Democratic) in 1990 to that in 1998?
Offer a terse response. 0.95. What is the ratio of the Gross enrolment ratio (%) in Malaysia in 1990 to that in 1998?
Your answer should be very brief. 0.97. What is the ratio of the Gross enrolment ratio (%) of East Asia (all income levels) in 1990 to that in 1999?
Your answer should be compact. 1.14. What is the ratio of the Gross enrolment ratio (%) in Low income in 1990 to that in 1999?
Provide a short and direct response. 0.85. What is the ratio of the Gross enrolment ratio (%) in Congo (Democratic) in 1990 to that in 1999?
Offer a terse response. 1.17. What is the ratio of the Gross enrolment ratio (%) of Malaysia in 1990 to that in 1999?
Provide a short and direct response. 0.97. What is the ratio of the Gross enrolment ratio (%) in East Asia (all income levels) in 1991 to that in 1992?
Provide a succinct answer. 1.02. What is the ratio of the Gross enrolment ratio (%) in Low income in 1991 to that in 1992?
Ensure brevity in your answer.  1.02. What is the ratio of the Gross enrolment ratio (%) in Congo (Democratic) in 1991 to that in 1992?
Ensure brevity in your answer.  1.03. What is the ratio of the Gross enrolment ratio (%) of Malaysia in 1991 to that in 1992?
Keep it short and to the point. 0.99. What is the ratio of the Gross enrolment ratio (%) of East Asia (all income levels) in 1991 to that in 1993?
Give a very brief answer. 1.05. What is the ratio of the Gross enrolment ratio (%) in Low income in 1991 to that in 1993?
Offer a terse response. 1.01. What is the ratio of the Gross enrolment ratio (%) in Congo (Democratic) in 1991 to that in 1993?
Give a very brief answer. 1.02. What is the ratio of the Gross enrolment ratio (%) of East Asia (all income levels) in 1991 to that in 1994?
Offer a very short reply. 1.06. What is the ratio of the Gross enrolment ratio (%) of Low income in 1991 to that in 1994?
Provide a short and direct response. 0.99. What is the ratio of the Gross enrolment ratio (%) of Congo (Democratic) in 1991 to that in 1994?
Keep it short and to the point. 1.05. What is the ratio of the Gross enrolment ratio (%) in Malaysia in 1991 to that in 1994?
Offer a terse response. 0.97. What is the ratio of the Gross enrolment ratio (%) in East Asia (all income levels) in 1991 to that in 1995?
Offer a terse response. 1.08. What is the ratio of the Gross enrolment ratio (%) of Low income in 1991 to that in 1995?
Give a very brief answer. 0.95. What is the ratio of the Gross enrolment ratio (%) in Congo (Democratic) in 1991 to that in 1995?
Provide a short and direct response. 1. What is the ratio of the Gross enrolment ratio (%) of Malaysia in 1991 to that in 1995?
Provide a succinct answer. 0.97. What is the ratio of the Gross enrolment ratio (%) of East Asia (all income levels) in 1991 to that in 1998?
Your answer should be compact. 1.11. What is the ratio of the Gross enrolment ratio (%) of Low income in 1991 to that in 1998?
Keep it short and to the point. 0.87. What is the ratio of the Gross enrolment ratio (%) in Congo (Democratic) in 1991 to that in 1998?
Ensure brevity in your answer.  1.22. What is the ratio of the Gross enrolment ratio (%) of Malaysia in 1991 to that in 1998?
Offer a very short reply. 0.98. What is the ratio of the Gross enrolment ratio (%) of East Asia (all income levels) in 1991 to that in 1999?
Offer a very short reply. 1.11. What is the ratio of the Gross enrolment ratio (%) in Low income in 1991 to that in 1999?
Make the answer very short. 0.88. What is the ratio of the Gross enrolment ratio (%) in Congo (Democratic) in 1991 to that in 1999?
Your answer should be very brief. 1.5. What is the ratio of the Gross enrolment ratio (%) of Malaysia in 1991 to that in 1999?
Provide a succinct answer. 0.98. What is the ratio of the Gross enrolment ratio (%) in East Asia (all income levels) in 1992 to that in 1993?
Offer a terse response. 1.02. What is the ratio of the Gross enrolment ratio (%) in Low income in 1992 to that in 1993?
Make the answer very short. 0.99. What is the ratio of the Gross enrolment ratio (%) in Congo (Democratic) in 1992 to that in 1993?
Ensure brevity in your answer.  0.99. What is the ratio of the Gross enrolment ratio (%) of Malaysia in 1992 to that in 1993?
Provide a short and direct response. 0.99. What is the ratio of the Gross enrolment ratio (%) of East Asia (all income levels) in 1992 to that in 1994?
Your response must be concise. 1.04. What is the ratio of the Gross enrolment ratio (%) of Low income in 1992 to that in 1994?
Provide a succinct answer. 0.98. What is the ratio of the Gross enrolment ratio (%) of Congo (Democratic) in 1992 to that in 1994?
Your answer should be very brief. 1.02. What is the ratio of the Gross enrolment ratio (%) of Malaysia in 1992 to that in 1994?
Your answer should be compact. 0.99. What is the ratio of the Gross enrolment ratio (%) of East Asia (all income levels) in 1992 to that in 1995?
Ensure brevity in your answer.  1.06. What is the ratio of the Gross enrolment ratio (%) in Low income in 1992 to that in 1995?
Provide a succinct answer. 0.93. What is the ratio of the Gross enrolment ratio (%) of Congo (Democratic) in 1992 to that in 1995?
Provide a short and direct response. 0.97. What is the ratio of the Gross enrolment ratio (%) of Malaysia in 1992 to that in 1995?
Keep it short and to the point. 0.98. What is the ratio of the Gross enrolment ratio (%) of East Asia (all income levels) in 1992 to that in 1998?
Provide a succinct answer. 1.09. What is the ratio of the Gross enrolment ratio (%) in Low income in 1992 to that in 1998?
Keep it short and to the point. 0.85. What is the ratio of the Gross enrolment ratio (%) in Congo (Democratic) in 1992 to that in 1998?
Provide a short and direct response. 1.18. What is the ratio of the Gross enrolment ratio (%) of Malaysia in 1992 to that in 1998?
Keep it short and to the point. 0.99. What is the ratio of the Gross enrolment ratio (%) of East Asia (all income levels) in 1992 to that in 1999?
Keep it short and to the point. 1.09. What is the ratio of the Gross enrolment ratio (%) of Low income in 1992 to that in 1999?
Your answer should be very brief. 0.86. What is the ratio of the Gross enrolment ratio (%) in Congo (Democratic) in 1992 to that in 1999?
Keep it short and to the point. 1.46. What is the ratio of the Gross enrolment ratio (%) in East Asia (all income levels) in 1993 to that in 1994?
Give a very brief answer. 1.02. What is the ratio of the Gross enrolment ratio (%) of Low income in 1993 to that in 1994?
Your answer should be very brief. 0.98. What is the ratio of the Gross enrolment ratio (%) in Congo (Democratic) in 1993 to that in 1994?
Make the answer very short. 1.03. What is the ratio of the Gross enrolment ratio (%) in Malaysia in 1993 to that in 1994?
Ensure brevity in your answer.  1. What is the ratio of the Gross enrolment ratio (%) of East Asia (all income levels) in 1993 to that in 1995?
Keep it short and to the point. 1.04. What is the ratio of the Gross enrolment ratio (%) of Low income in 1993 to that in 1995?
Offer a terse response. 0.94. What is the ratio of the Gross enrolment ratio (%) in Congo (Democratic) in 1993 to that in 1995?
Provide a short and direct response. 0.97. What is the ratio of the Gross enrolment ratio (%) in Malaysia in 1993 to that in 1995?
Offer a terse response. 0.99. What is the ratio of the Gross enrolment ratio (%) of East Asia (all income levels) in 1993 to that in 1998?
Offer a terse response. 1.06. What is the ratio of the Gross enrolment ratio (%) in Low income in 1993 to that in 1998?
Give a very brief answer. 0.86. What is the ratio of the Gross enrolment ratio (%) in Congo (Democratic) in 1993 to that in 1998?
Give a very brief answer. 1.19. What is the ratio of the Gross enrolment ratio (%) in East Asia (all income levels) in 1993 to that in 1999?
Make the answer very short. 1.06. What is the ratio of the Gross enrolment ratio (%) in Low income in 1993 to that in 1999?
Provide a short and direct response. 0.87. What is the ratio of the Gross enrolment ratio (%) of Congo (Democratic) in 1993 to that in 1999?
Provide a short and direct response. 1.47. What is the ratio of the Gross enrolment ratio (%) of Malaysia in 1993 to that in 1999?
Make the answer very short. 1. What is the ratio of the Gross enrolment ratio (%) of East Asia (all income levels) in 1994 to that in 1995?
Provide a succinct answer. 1.02. What is the ratio of the Gross enrolment ratio (%) of Low income in 1994 to that in 1995?
Offer a very short reply. 0.96. What is the ratio of the Gross enrolment ratio (%) in Congo (Democratic) in 1994 to that in 1995?
Give a very brief answer. 0.95. What is the ratio of the Gross enrolment ratio (%) of East Asia (all income levels) in 1994 to that in 1998?
Offer a terse response. 1.04. What is the ratio of the Gross enrolment ratio (%) in Low income in 1994 to that in 1998?
Your response must be concise. 0.87. What is the ratio of the Gross enrolment ratio (%) of Congo (Democratic) in 1994 to that in 1998?
Make the answer very short. 1.16. What is the ratio of the Gross enrolment ratio (%) in Malaysia in 1994 to that in 1998?
Provide a short and direct response. 1. What is the ratio of the Gross enrolment ratio (%) of East Asia (all income levels) in 1994 to that in 1999?
Offer a very short reply. 1.04. What is the ratio of the Gross enrolment ratio (%) in Low income in 1994 to that in 1999?
Make the answer very short. 0.88. What is the ratio of the Gross enrolment ratio (%) in Congo (Democratic) in 1994 to that in 1999?
Keep it short and to the point. 1.43. What is the ratio of the Gross enrolment ratio (%) of Malaysia in 1994 to that in 1999?
Offer a very short reply. 1.01. What is the ratio of the Gross enrolment ratio (%) in East Asia (all income levels) in 1995 to that in 1998?
Offer a terse response. 1.03. What is the ratio of the Gross enrolment ratio (%) in Low income in 1995 to that in 1998?
Your answer should be very brief. 0.92. What is the ratio of the Gross enrolment ratio (%) of Congo (Democratic) in 1995 to that in 1998?
Your response must be concise. 1.23. What is the ratio of the Gross enrolment ratio (%) in Malaysia in 1995 to that in 1998?
Your answer should be compact. 1.01. What is the ratio of the Gross enrolment ratio (%) of Low income in 1995 to that in 1999?
Your answer should be compact. 0.92. What is the ratio of the Gross enrolment ratio (%) of Congo (Democratic) in 1995 to that in 1999?
Your answer should be compact. 1.51. What is the ratio of the Gross enrolment ratio (%) of Malaysia in 1995 to that in 1999?
Make the answer very short. 1.01. What is the ratio of the Gross enrolment ratio (%) of East Asia (all income levels) in 1998 to that in 1999?
Keep it short and to the point. 1. What is the ratio of the Gross enrolment ratio (%) in Low income in 1998 to that in 1999?
Offer a very short reply. 1.01. What is the ratio of the Gross enrolment ratio (%) in Congo (Democratic) in 1998 to that in 1999?
Offer a terse response. 1.23. What is the difference between the highest and the second highest Gross enrolment ratio (%) of East Asia (all income levels)?
Offer a very short reply. 2.99. What is the difference between the highest and the second highest Gross enrolment ratio (%) of Low income?
Provide a short and direct response. 0.63. What is the difference between the highest and the second highest Gross enrolment ratio (%) of Congo (Democratic)?
Make the answer very short. 0.38. What is the difference between the highest and the second highest Gross enrolment ratio (%) in Malaysia?
Your response must be concise. 0.61. What is the difference between the highest and the lowest Gross enrolment ratio (%) in East Asia (all income levels)?
Keep it short and to the point. 14.49. What is the difference between the highest and the lowest Gross enrolment ratio (%) in Low income?
Ensure brevity in your answer.  11.48. What is the difference between the highest and the lowest Gross enrolment ratio (%) of Congo (Democratic)?
Offer a terse response. 26.9. What is the difference between the highest and the lowest Gross enrolment ratio (%) of Malaysia?
Make the answer very short. 4.09. 